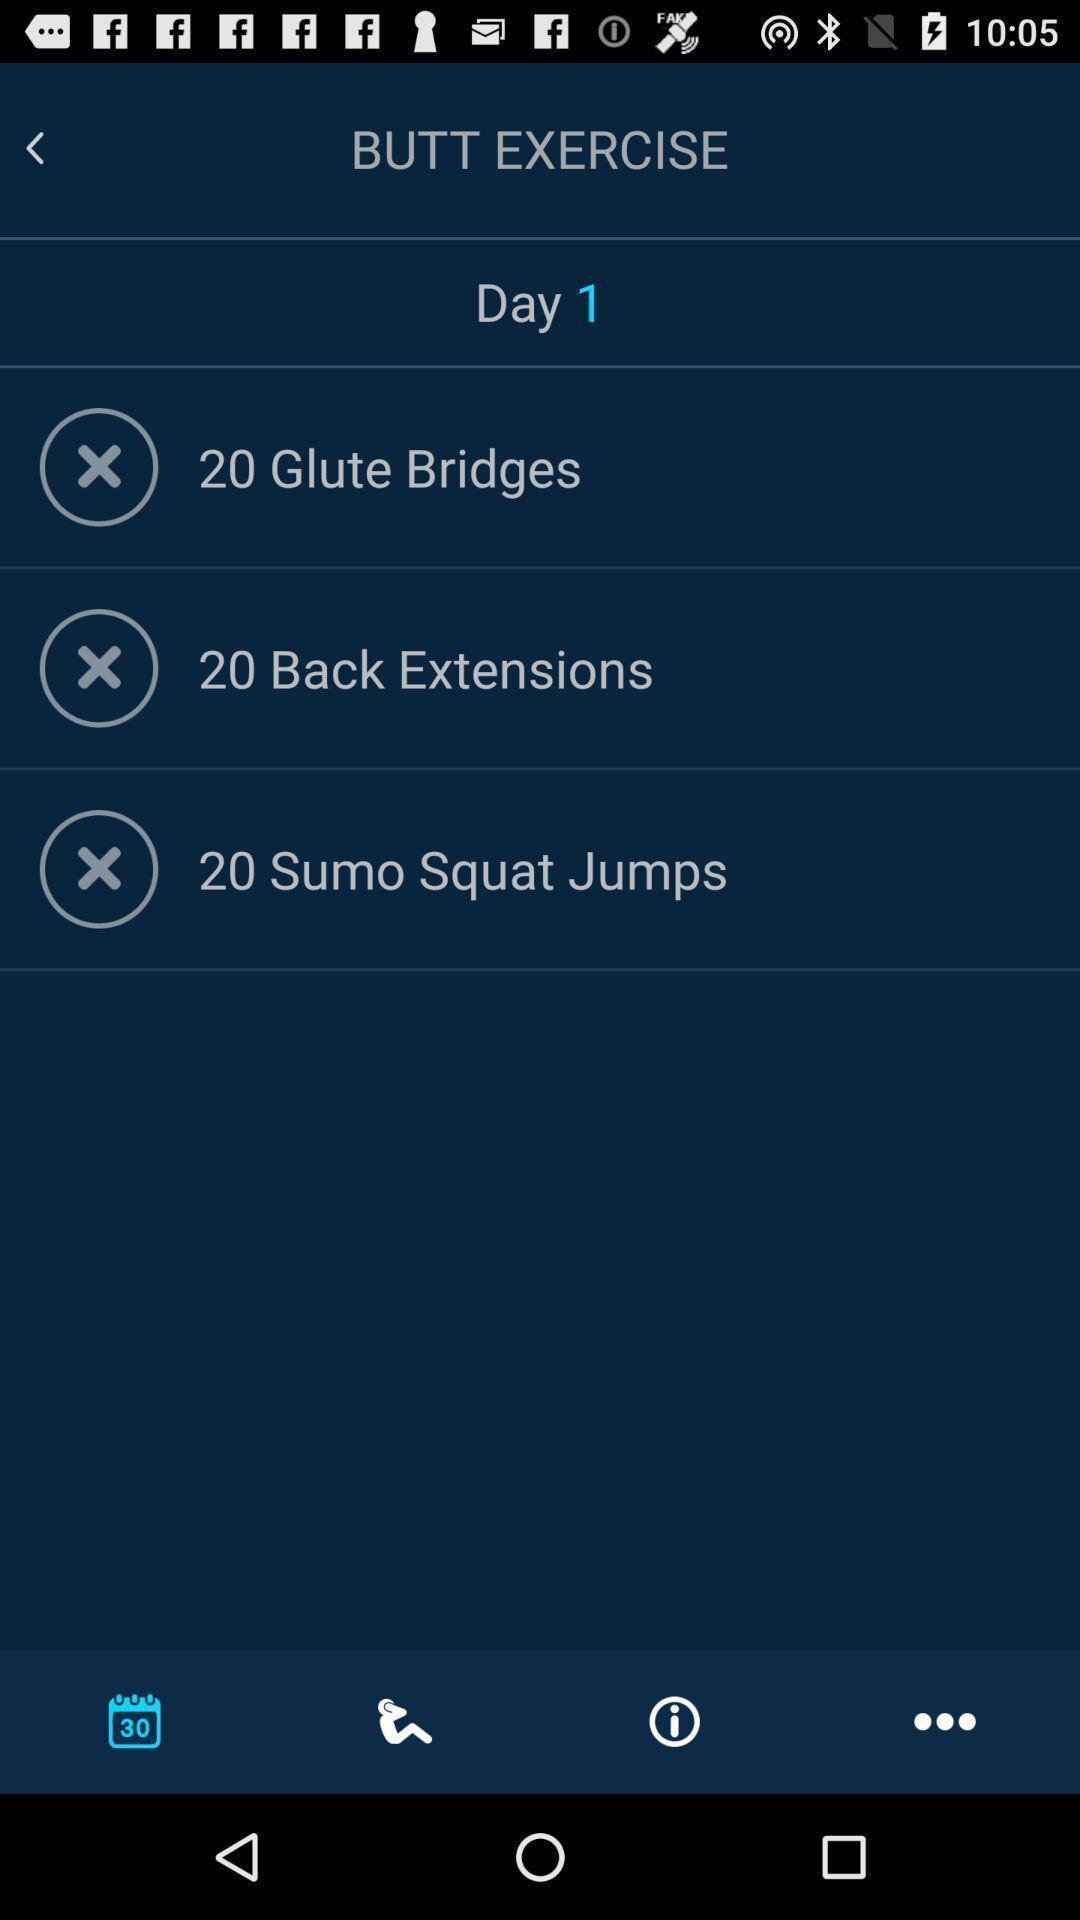Give me a summary of this screen capture. Window displaying an exercise app. 